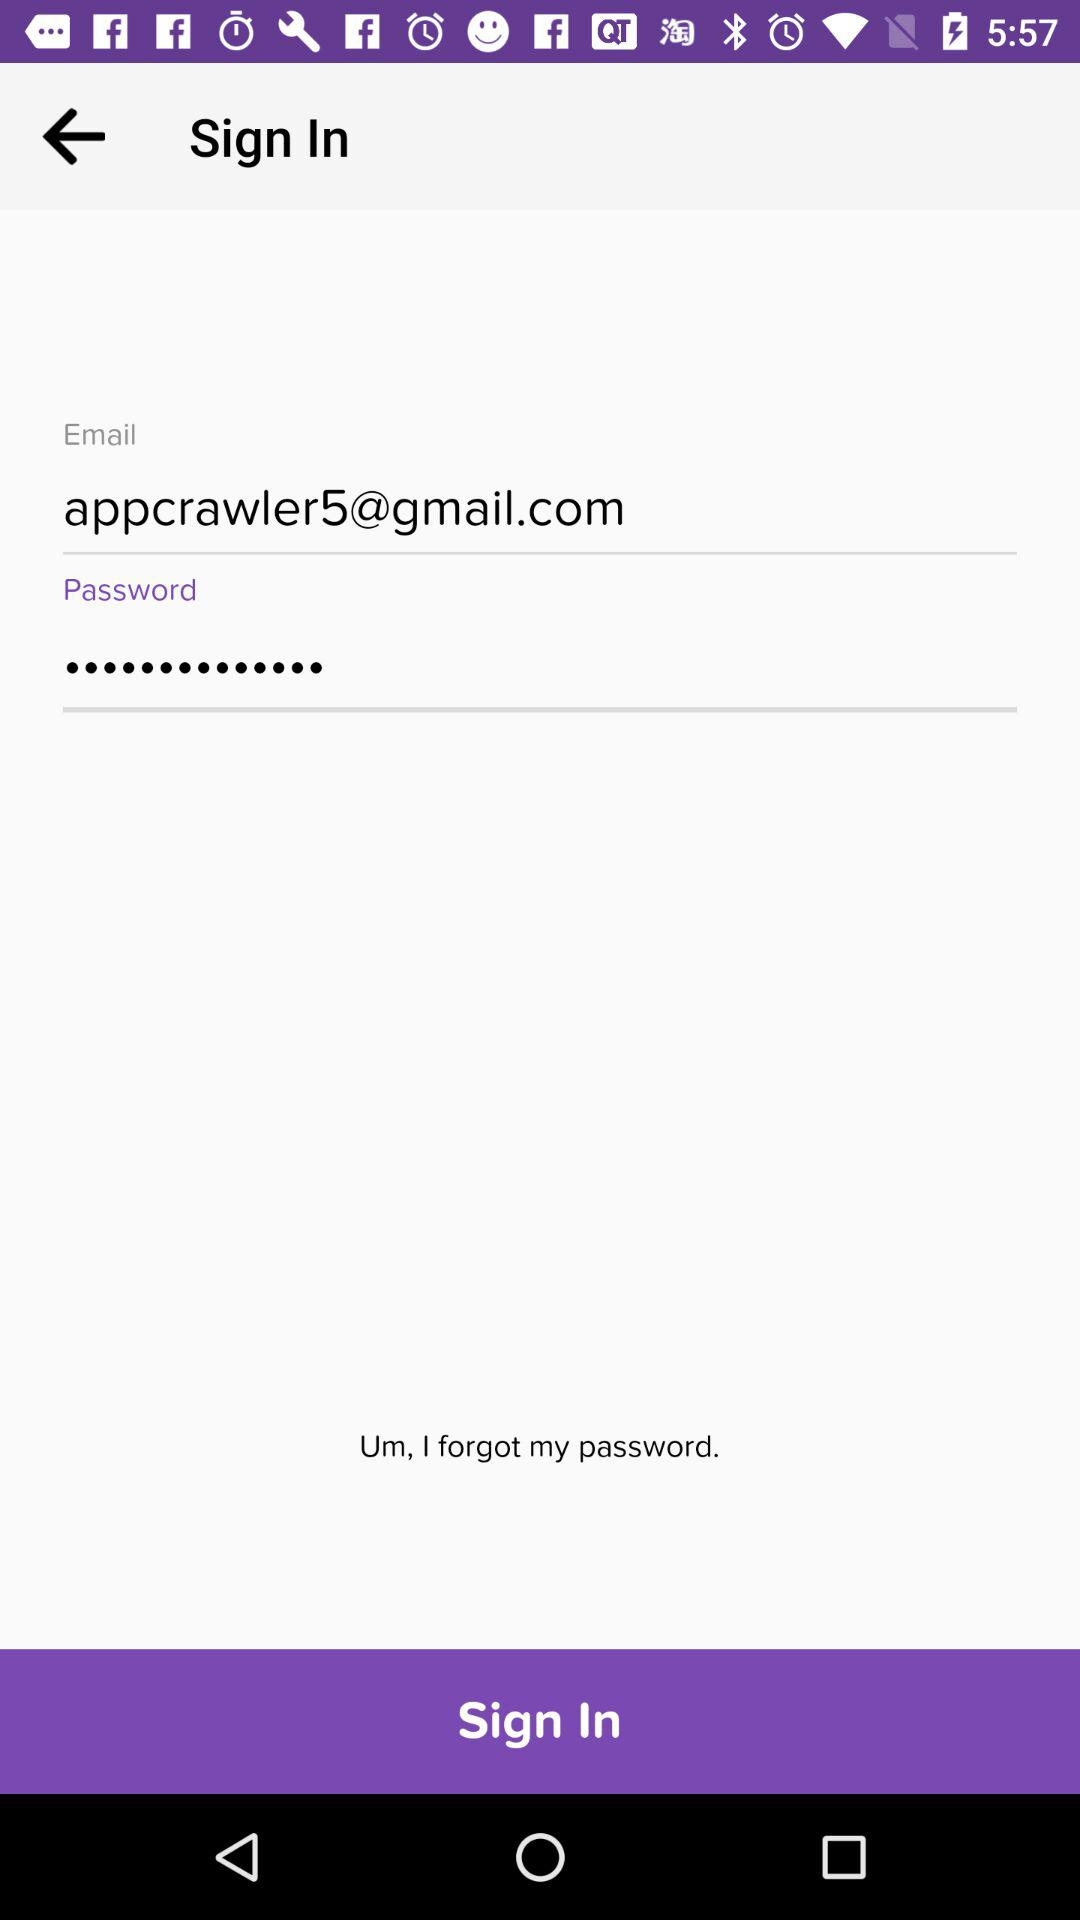What is the email address? The email address is appcrawler5@gmail.com. 